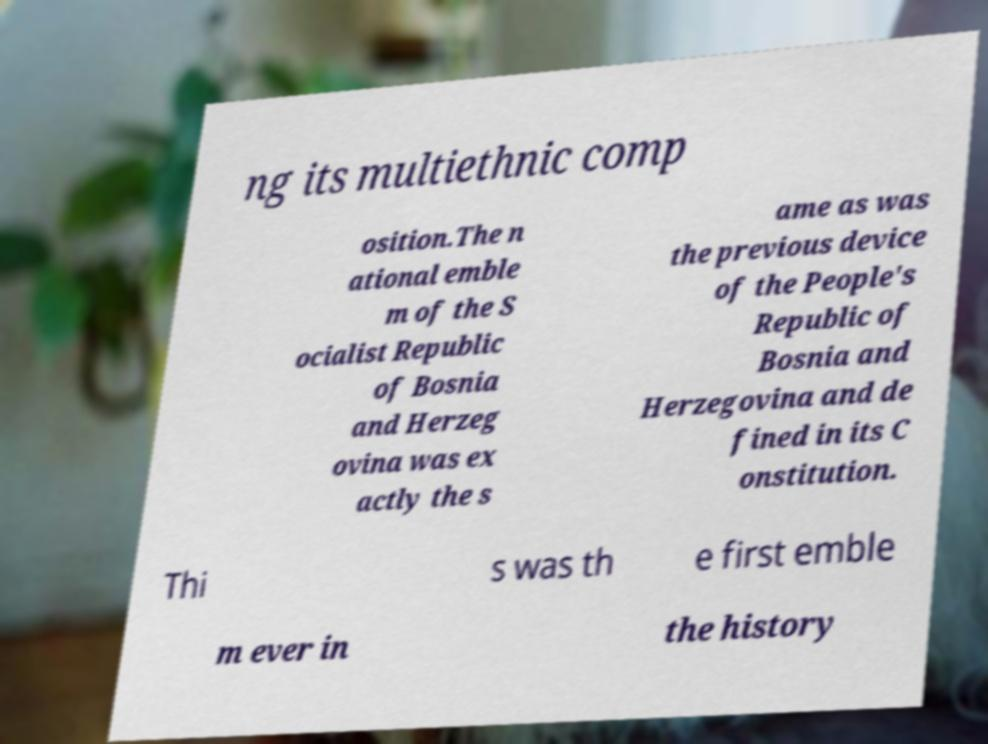For documentation purposes, I need the text within this image transcribed. Could you provide that? ng its multiethnic comp osition.The n ational emble m of the S ocialist Republic of Bosnia and Herzeg ovina was ex actly the s ame as was the previous device of the People's Republic of Bosnia and Herzegovina and de fined in its C onstitution. Thi s was th e first emble m ever in the history 